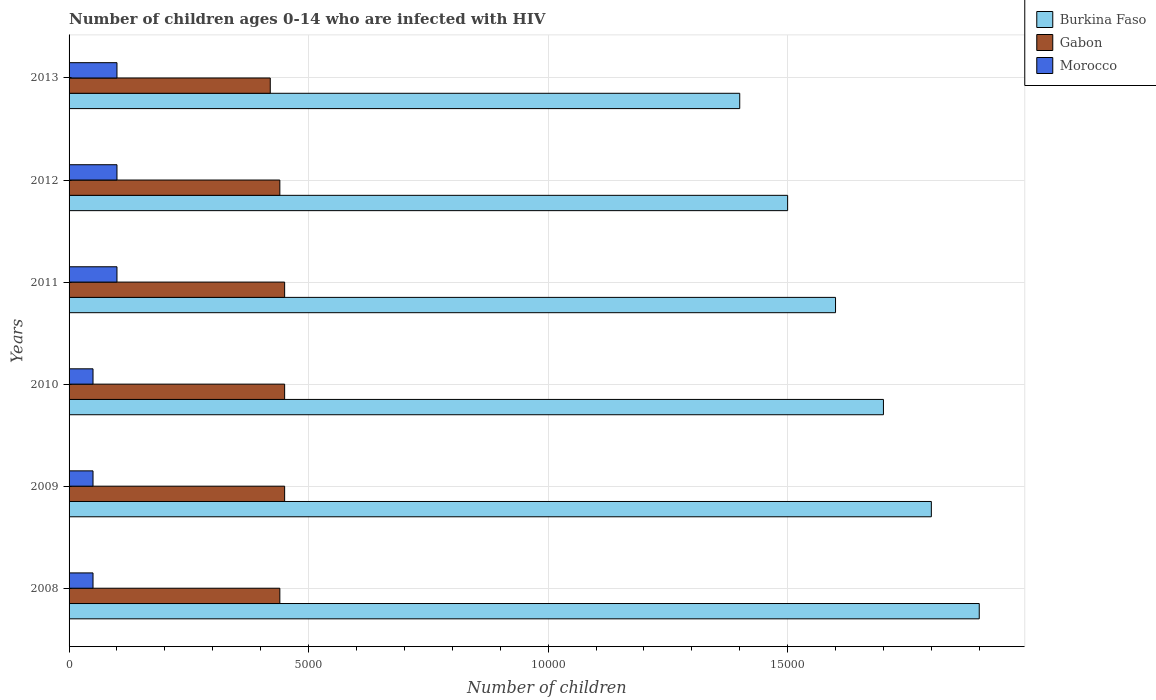Are the number of bars per tick equal to the number of legend labels?
Your answer should be compact. Yes. Are the number of bars on each tick of the Y-axis equal?
Offer a terse response. Yes. How many bars are there on the 6th tick from the bottom?
Ensure brevity in your answer.  3. What is the label of the 6th group of bars from the top?
Provide a short and direct response. 2008. In how many cases, is the number of bars for a given year not equal to the number of legend labels?
Your answer should be very brief. 0. What is the number of HIV infected children in Burkina Faso in 2009?
Your answer should be very brief. 1.80e+04. Across all years, what is the maximum number of HIV infected children in Burkina Faso?
Provide a succinct answer. 1.90e+04. Across all years, what is the minimum number of HIV infected children in Morocco?
Keep it short and to the point. 500. In which year was the number of HIV infected children in Burkina Faso minimum?
Make the answer very short. 2013. What is the total number of HIV infected children in Gabon in the graph?
Your answer should be very brief. 2.65e+04. What is the difference between the number of HIV infected children in Burkina Faso in 2011 and the number of HIV infected children in Morocco in 2012?
Keep it short and to the point. 1.50e+04. What is the average number of HIV infected children in Burkina Faso per year?
Your answer should be very brief. 1.65e+04. In the year 2013, what is the difference between the number of HIV infected children in Gabon and number of HIV infected children in Burkina Faso?
Keep it short and to the point. -9800. Is the difference between the number of HIV infected children in Gabon in 2009 and 2011 greater than the difference between the number of HIV infected children in Burkina Faso in 2009 and 2011?
Your response must be concise. No. What is the difference between the highest and the second highest number of HIV infected children in Gabon?
Your answer should be compact. 0. What is the difference between the highest and the lowest number of HIV infected children in Gabon?
Provide a succinct answer. 300. Is the sum of the number of HIV infected children in Gabon in 2008 and 2010 greater than the maximum number of HIV infected children in Burkina Faso across all years?
Ensure brevity in your answer.  No. What does the 3rd bar from the top in 2012 represents?
Provide a succinct answer. Burkina Faso. What does the 3rd bar from the bottom in 2010 represents?
Make the answer very short. Morocco. How many years are there in the graph?
Offer a terse response. 6. What is the difference between two consecutive major ticks on the X-axis?
Give a very brief answer. 5000. Does the graph contain any zero values?
Keep it short and to the point. No. Does the graph contain grids?
Make the answer very short. Yes. Where does the legend appear in the graph?
Ensure brevity in your answer.  Top right. How many legend labels are there?
Keep it short and to the point. 3. How are the legend labels stacked?
Offer a very short reply. Vertical. What is the title of the graph?
Provide a short and direct response. Number of children ages 0-14 who are infected with HIV. Does "Tunisia" appear as one of the legend labels in the graph?
Ensure brevity in your answer.  No. What is the label or title of the X-axis?
Give a very brief answer. Number of children. What is the Number of children in Burkina Faso in 2008?
Keep it short and to the point. 1.90e+04. What is the Number of children of Gabon in 2008?
Make the answer very short. 4400. What is the Number of children in Morocco in 2008?
Your answer should be very brief. 500. What is the Number of children in Burkina Faso in 2009?
Ensure brevity in your answer.  1.80e+04. What is the Number of children of Gabon in 2009?
Provide a succinct answer. 4500. What is the Number of children of Burkina Faso in 2010?
Your answer should be compact. 1.70e+04. What is the Number of children in Gabon in 2010?
Ensure brevity in your answer.  4500. What is the Number of children in Morocco in 2010?
Keep it short and to the point. 500. What is the Number of children in Burkina Faso in 2011?
Provide a short and direct response. 1.60e+04. What is the Number of children in Gabon in 2011?
Your answer should be compact. 4500. What is the Number of children of Morocco in 2011?
Offer a very short reply. 1000. What is the Number of children in Burkina Faso in 2012?
Provide a short and direct response. 1.50e+04. What is the Number of children in Gabon in 2012?
Make the answer very short. 4400. What is the Number of children of Burkina Faso in 2013?
Give a very brief answer. 1.40e+04. What is the Number of children of Gabon in 2013?
Keep it short and to the point. 4200. Across all years, what is the maximum Number of children in Burkina Faso?
Your answer should be compact. 1.90e+04. Across all years, what is the maximum Number of children in Gabon?
Provide a short and direct response. 4500. Across all years, what is the maximum Number of children in Morocco?
Ensure brevity in your answer.  1000. Across all years, what is the minimum Number of children of Burkina Faso?
Offer a terse response. 1.40e+04. Across all years, what is the minimum Number of children in Gabon?
Provide a short and direct response. 4200. Across all years, what is the minimum Number of children in Morocco?
Make the answer very short. 500. What is the total Number of children in Burkina Faso in the graph?
Offer a very short reply. 9.90e+04. What is the total Number of children in Gabon in the graph?
Offer a terse response. 2.65e+04. What is the total Number of children of Morocco in the graph?
Keep it short and to the point. 4500. What is the difference between the Number of children of Gabon in 2008 and that in 2009?
Ensure brevity in your answer.  -100. What is the difference between the Number of children in Burkina Faso in 2008 and that in 2010?
Your response must be concise. 2000. What is the difference between the Number of children of Gabon in 2008 and that in 2010?
Make the answer very short. -100. What is the difference between the Number of children in Burkina Faso in 2008 and that in 2011?
Keep it short and to the point. 3000. What is the difference between the Number of children in Gabon in 2008 and that in 2011?
Your response must be concise. -100. What is the difference between the Number of children of Morocco in 2008 and that in 2011?
Your answer should be very brief. -500. What is the difference between the Number of children in Burkina Faso in 2008 and that in 2012?
Make the answer very short. 4000. What is the difference between the Number of children of Gabon in 2008 and that in 2012?
Your answer should be very brief. 0. What is the difference between the Number of children in Morocco in 2008 and that in 2012?
Offer a terse response. -500. What is the difference between the Number of children of Morocco in 2008 and that in 2013?
Your answer should be compact. -500. What is the difference between the Number of children in Morocco in 2009 and that in 2010?
Your answer should be very brief. 0. What is the difference between the Number of children in Burkina Faso in 2009 and that in 2011?
Make the answer very short. 2000. What is the difference between the Number of children in Gabon in 2009 and that in 2011?
Make the answer very short. 0. What is the difference between the Number of children of Morocco in 2009 and that in 2011?
Keep it short and to the point. -500. What is the difference between the Number of children of Burkina Faso in 2009 and that in 2012?
Offer a very short reply. 3000. What is the difference between the Number of children of Gabon in 2009 and that in 2012?
Your answer should be compact. 100. What is the difference between the Number of children in Morocco in 2009 and that in 2012?
Your answer should be very brief. -500. What is the difference between the Number of children of Burkina Faso in 2009 and that in 2013?
Your answer should be very brief. 4000. What is the difference between the Number of children of Gabon in 2009 and that in 2013?
Your response must be concise. 300. What is the difference between the Number of children in Morocco in 2009 and that in 2013?
Your answer should be very brief. -500. What is the difference between the Number of children of Morocco in 2010 and that in 2011?
Your answer should be compact. -500. What is the difference between the Number of children of Burkina Faso in 2010 and that in 2012?
Offer a terse response. 2000. What is the difference between the Number of children of Morocco in 2010 and that in 2012?
Provide a short and direct response. -500. What is the difference between the Number of children of Burkina Faso in 2010 and that in 2013?
Make the answer very short. 3000. What is the difference between the Number of children of Gabon in 2010 and that in 2013?
Offer a terse response. 300. What is the difference between the Number of children of Morocco in 2010 and that in 2013?
Keep it short and to the point. -500. What is the difference between the Number of children in Morocco in 2011 and that in 2012?
Your response must be concise. 0. What is the difference between the Number of children in Burkina Faso in 2011 and that in 2013?
Offer a terse response. 2000. What is the difference between the Number of children in Gabon in 2011 and that in 2013?
Offer a terse response. 300. What is the difference between the Number of children of Gabon in 2012 and that in 2013?
Your answer should be compact. 200. What is the difference between the Number of children in Burkina Faso in 2008 and the Number of children in Gabon in 2009?
Your answer should be compact. 1.45e+04. What is the difference between the Number of children in Burkina Faso in 2008 and the Number of children in Morocco in 2009?
Provide a succinct answer. 1.85e+04. What is the difference between the Number of children in Gabon in 2008 and the Number of children in Morocco in 2009?
Provide a succinct answer. 3900. What is the difference between the Number of children in Burkina Faso in 2008 and the Number of children in Gabon in 2010?
Your response must be concise. 1.45e+04. What is the difference between the Number of children of Burkina Faso in 2008 and the Number of children of Morocco in 2010?
Your response must be concise. 1.85e+04. What is the difference between the Number of children of Gabon in 2008 and the Number of children of Morocco in 2010?
Your response must be concise. 3900. What is the difference between the Number of children in Burkina Faso in 2008 and the Number of children in Gabon in 2011?
Offer a very short reply. 1.45e+04. What is the difference between the Number of children in Burkina Faso in 2008 and the Number of children in Morocco in 2011?
Provide a short and direct response. 1.80e+04. What is the difference between the Number of children of Gabon in 2008 and the Number of children of Morocco in 2011?
Provide a short and direct response. 3400. What is the difference between the Number of children in Burkina Faso in 2008 and the Number of children in Gabon in 2012?
Your answer should be very brief. 1.46e+04. What is the difference between the Number of children in Burkina Faso in 2008 and the Number of children in Morocco in 2012?
Give a very brief answer. 1.80e+04. What is the difference between the Number of children in Gabon in 2008 and the Number of children in Morocco in 2012?
Provide a short and direct response. 3400. What is the difference between the Number of children in Burkina Faso in 2008 and the Number of children in Gabon in 2013?
Make the answer very short. 1.48e+04. What is the difference between the Number of children in Burkina Faso in 2008 and the Number of children in Morocco in 2013?
Your answer should be compact. 1.80e+04. What is the difference between the Number of children in Gabon in 2008 and the Number of children in Morocco in 2013?
Make the answer very short. 3400. What is the difference between the Number of children of Burkina Faso in 2009 and the Number of children of Gabon in 2010?
Keep it short and to the point. 1.35e+04. What is the difference between the Number of children in Burkina Faso in 2009 and the Number of children in Morocco in 2010?
Give a very brief answer. 1.75e+04. What is the difference between the Number of children in Gabon in 2009 and the Number of children in Morocco in 2010?
Provide a succinct answer. 4000. What is the difference between the Number of children in Burkina Faso in 2009 and the Number of children in Gabon in 2011?
Your response must be concise. 1.35e+04. What is the difference between the Number of children in Burkina Faso in 2009 and the Number of children in Morocco in 2011?
Your response must be concise. 1.70e+04. What is the difference between the Number of children in Gabon in 2009 and the Number of children in Morocco in 2011?
Your answer should be very brief. 3500. What is the difference between the Number of children in Burkina Faso in 2009 and the Number of children in Gabon in 2012?
Ensure brevity in your answer.  1.36e+04. What is the difference between the Number of children in Burkina Faso in 2009 and the Number of children in Morocco in 2012?
Offer a very short reply. 1.70e+04. What is the difference between the Number of children of Gabon in 2009 and the Number of children of Morocco in 2012?
Your answer should be very brief. 3500. What is the difference between the Number of children of Burkina Faso in 2009 and the Number of children of Gabon in 2013?
Your answer should be very brief. 1.38e+04. What is the difference between the Number of children of Burkina Faso in 2009 and the Number of children of Morocco in 2013?
Give a very brief answer. 1.70e+04. What is the difference between the Number of children of Gabon in 2009 and the Number of children of Morocco in 2013?
Provide a short and direct response. 3500. What is the difference between the Number of children in Burkina Faso in 2010 and the Number of children in Gabon in 2011?
Ensure brevity in your answer.  1.25e+04. What is the difference between the Number of children of Burkina Faso in 2010 and the Number of children of Morocco in 2011?
Your answer should be very brief. 1.60e+04. What is the difference between the Number of children in Gabon in 2010 and the Number of children in Morocco in 2011?
Offer a terse response. 3500. What is the difference between the Number of children in Burkina Faso in 2010 and the Number of children in Gabon in 2012?
Your answer should be very brief. 1.26e+04. What is the difference between the Number of children of Burkina Faso in 2010 and the Number of children of Morocco in 2012?
Make the answer very short. 1.60e+04. What is the difference between the Number of children of Gabon in 2010 and the Number of children of Morocco in 2012?
Offer a very short reply. 3500. What is the difference between the Number of children in Burkina Faso in 2010 and the Number of children in Gabon in 2013?
Provide a short and direct response. 1.28e+04. What is the difference between the Number of children of Burkina Faso in 2010 and the Number of children of Morocco in 2013?
Keep it short and to the point. 1.60e+04. What is the difference between the Number of children of Gabon in 2010 and the Number of children of Morocco in 2013?
Provide a short and direct response. 3500. What is the difference between the Number of children in Burkina Faso in 2011 and the Number of children in Gabon in 2012?
Your response must be concise. 1.16e+04. What is the difference between the Number of children of Burkina Faso in 2011 and the Number of children of Morocco in 2012?
Your answer should be compact. 1.50e+04. What is the difference between the Number of children of Gabon in 2011 and the Number of children of Morocco in 2012?
Make the answer very short. 3500. What is the difference between the Number of children of Burkina Faso in 2011 and the Number of children of Gabon in 2013?
Your answer should be compact. 1.18e+04. What is the difference between the Number of children of Burkina Faso in 2011 and the Number of children of Morocco in 2013?
Your answer should be compact. 1.50e+04. What is the difference between the Number of children in Gabon in 2011 and the Number of children in Morocco in 2013?
Your answer should be very brief. 3500. What is the difference between the Number of children of Burkina Faso in 2012 and the Number of children of Gabon in 2013?
Make the answer very short. 1.08e+04. What is the difference between the Number of children of Burkina Faso in 2012 and the Number of children of Morocco in 2013?
Provide a short and direct response. 1.40e+04. What is the difference between the Number of children in Gabon in 2012 and the Number of children in Morocco in 2013?
Your response must be concise. 3400. What is the average Number of children in Burkina Faso per year?
Your response must be concise. 1.65e+04. What is the average Number of children of Gabon per year?
Offer a terse response. 4416.67. What is the average Number of children in Morocco per year?
Make the answer very short. 750. In the year 2008, what is the difference between the Number of children in Burkina Faso and Number of children in Gabon?
Ensure brevity in your answer.  1.46e+04. In the year 2008, what is the difference between the Number of children in Burkina Faso and Number of children in Morocco?
Give a very brief answer. 1.85e+04. In the year 2008, what is the difference between the Number of children of Gabon and Number of children of Morocco?
Provide a succinct answer. 3900. In the year 2009, what is the difference between the Number of children in Burkina Faso and Number of children in Gabon?
Your answer should be compact. 1.35e+04. In the year 2009, what is the difference between the Number of children of Burkina Faso and Number of children of Morocco?
Offer a very short reply. 1.75e+04. In the year 2009, what is the difference between the Number of children in Gabon and Number of children in Morocco?
Provide a short and direct response. 4000. In the year 2010, what is the difference between the Number of children in Burkina Faso and Number of children in Gabon?
Offer a terse response. 1.25e+04. In the year 2010, what is the difference between the Number of children in Burkina Faso and Number of children in Morocco?
Your response must be concise. 1.65e+04. In the year 2010, what is the difference between the Number of children in Gabon and Number of children in Morocco?
Give a very brief answer. 4000. In the year 2011, what is the difference between the Number of children of Burkina Faso and Number of children of Gabon?
Offer a very short reply. 1.15e+04. In the year 2011, what is the difference between the Number of children in Burkina Faso and Number of children in Morocco?
Provide a short and direct response. 1.50e+04. In the year 2011, what is the difference between the Number of children of Gabon and Number of children of Morocco?
Your response must be concise. 3500. In the year 2012, what is the difference between the Number of children of Burkina Faso and Number of children of Gabon?
Your answer should be very brief. 1.06e+04. In the year 2012, what is the difference between the Number of children of Burkina Faso and Number of children of Morocco?
Offer a very short reply. 1.40e+04. In the year 2012, what is the difference between the Number of children in Gabon and Number of children in Morocco?
Give a very brief answer. 3400. In the year 2013, what is the difference between the Number of children of Burkina Faso and Number of children of Gabon?
Give a very brief answer. 9800. In the year 2013, what is the difference between the Number of children of Burkina Faso and Number of children of Morocco?
Make the answer very short. 1.30e+04. In the year 2013, what is the difference between the Number of children of Gabon and Number of children of Morocco?
Provide a succinct answer. 3200. What is the ratio of the Number of children of Burkina Faso in 2008 to that in 2009?
Offer a very short reply. 1.06. What is the ratio of the Number of children in Gabon in 2008 to that in 2009?
Make the answer very short. 0.98. What is the ratio of the Number of children in Burkina Faso in 2008 to that in 2010?
Keep it short and to the point. 1.12. What is the ratio of the Number of children in Gabon in 2008 to that in 2010?
Offer a terse response. 0.98. What is the ratio of the Number of children of Burkina Faso in 2008 to that in 2011?
Give a very brief answer. 1.19. What is the ratio of the Number of children of Gabon in 2008 to that in 2011?
Ensure brevity in your answer.  0.98. What is the ratio of the Number of children of Morocco in 2008 to that in 2011?
Provide a short and direct response. 0.5. What is the ratio of the Number of children in Burkina Faso in 2008 to that in 2012?
Your answer should be compact. 1.27. What is the ratio of the Number of children of Morocco in 2008 to that in 2012?
Offer a terse response. 0.5. What is the ratio of the Number of children of Burkina Faso in 2008 to that in 2013?
Ensure brevity in your answer.  1.36. What is the ratio of the Number of children of Gabon in 2008 to that in 2013?
Your answer should be very brief. 1.05. What is the ratio of the Number of children in Burkina Faso in 2009 to that in 2010?
Ensure brevity in your answer.  1.06. What is the ratio of the Number of children in Morocco in 2009 to that in 2010?
Make the answer very short. 1. What is the ratio of the Number of children of Burkina Faso in 2009 to that in 2011?
Your answer should be very brief. 1.12. What is the ratio of the Number of children of Morocco in 2009 to that in 2011?
Make the answer very short. 0.5. What is the ratio of the Number of children in Burkina Faso in 2009 to that in 2012?
Keep it short and to the point. 1.2. What is the ratio of the Number of children in Gabon in 2009 to that in 2012?
Keep it short and to the point. 1.02. What is the ratio of the Number of children of Morocco in 2009 to that in 2012?
Offer a terse response. 0.5. What is the ratio of the Number of children of Burkina Faso in 2009 to that in 2013?
Provide a short and direct response. 1.29. What is the ratio of the Number of children in Gabon in 2009 to that in 2013?
Make the answer very short. 1.07. What is the ratio of the Number of children of Morocco in 2009 to that in 2013?
Offer a terse response. 0.5. What is the ratio of the Number of children in Burkina Faso in 2010 to that in 2011?
Make the answer very short. 1.06. What is the ratio of the Number of children of Burkina Faso in 2010 to that in 2012?
Your response must be concise. 1.13. What is the ratio of the Number of children of Gabon in 2010 to that in 2012?
Your answer should be very brief. 1.02. What is the ratio of the Number of children of Burkina Faso in 2010 to that in 2013?
Give a very brief answer. 1.21. What is the ratio of the Number of children in Gabon in 2010 to that in 2013?
Your response must be concise. 1.07. What is the ratio of the Number of children in Morocco in 2010 to that in 2013?
Keep it short and to the point. 0.5. What is the ratio of the Number of children of Burkina Faso in 2011 to that in 2012?
Make the answer very short. 1.07. What is the ratio of the Number of children in Gabon in 2011 to that in 2012?
Offer a very short reply. 1.02. What is the ratio of the Number of children in Morocco in 2011 to that in 2012?
Provide a succinct answer. 1. What is the ratio of the Number of children in Gabon in 2011 to that in 2013?
Offer a very short reply. 1.07. What is the ratio of the Number of children of Morocco in 2011 to that in 2013?
Offer a terse response. 1. What is the ratio of the Number of children in Burkina Faso in 2012 to that in 2013?
Keep it short and to the point. 1.07. What is the ratio of the Number of children in Gabon in 2012 to that in 2013?
Offer a very short reply. 1.05. What is the difference between the highest and the second highest Number of children of Burkina Faso?
Provide a succinct answer. 1000. What is the difference between the highest and the lowest Number of children of Gabon?
Your answer should be very brief. 300. What is the difference between the highest and the lowest Number of children of Morocco?
Provide a short and direct response. 500. 